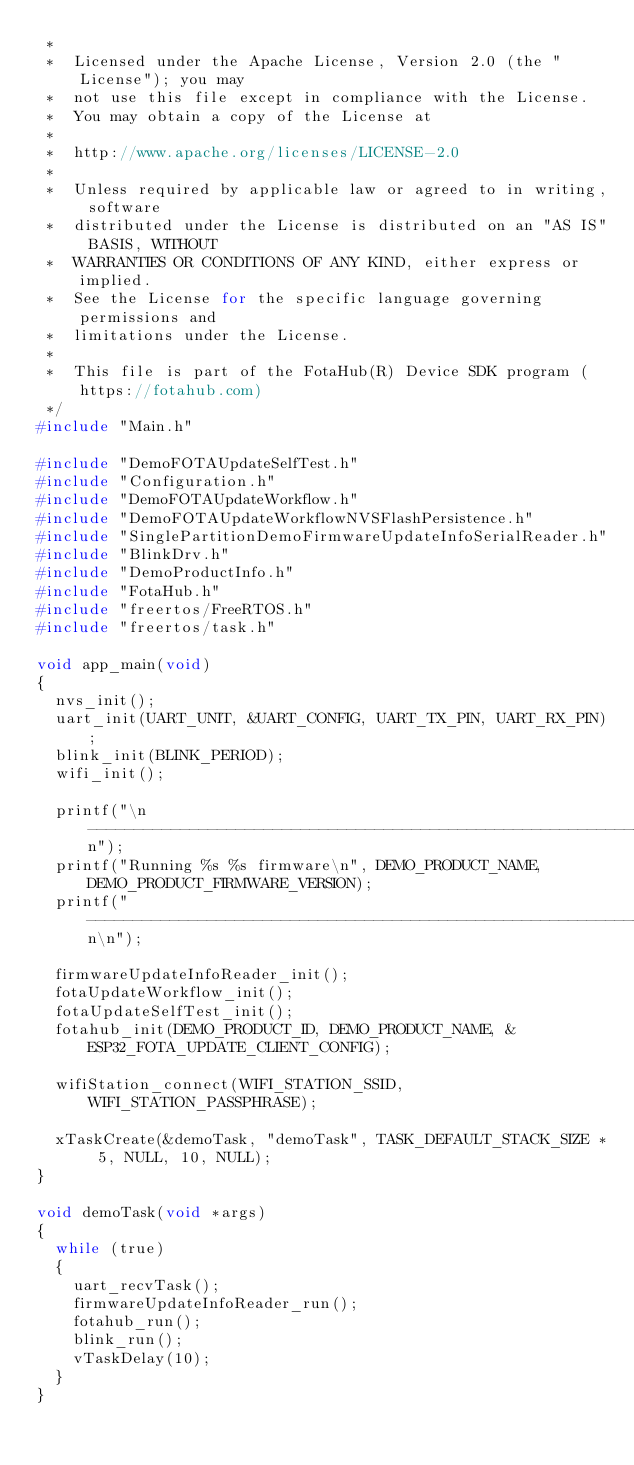<code> <loc_0><loc_0><loc_500><loc_500><_C_> *
 *  Licensed under the Apache License, Version 2.0 (the "License"); you may
 *  not use this file except in compliance with the License.
 *  You may obtain a copy of the License at
 *
 *  http://www.apache.org/licenses/LICENSE-2.0
 *
 *  Unless required by applicable law or agreed to in writing, software
 *  distributed under the License is distributed on an "AS IS" BASIS, WITHOUT
 *  WARRANTIES OR CONDITIONS OF ANY KIND, either express or implied.
 *  See the License for the specific language governing permissions and
 *  limitations under the License.
 *
 *  This file is part of the FotaHub(R) Device SDK program (https://fotahub.com)
 */
#include "Main.h"

#include "DemoFOTAUpdateSelfTest.h"
#include "Configuration.h"
#include "DemoFOTAUpdateWorkflow.h"
#include "DemoFOTAUpdateWorkflowNVSFlashPersistence.h"
#include "SinglePartitionDemoFirmwareUpdateInfoSerialReader.h"
#include "BlinkDrv.h"
#include "DemoProductInfo.h"
#include "FotaHub.h"
#include "freertos/FreeRTOS.h"
#include "freertos/task.h"

void app_main(void)
{
  nvs_init();
  uart_init(UART_UNIT, &UART_CONFIG, UART_TX_PIN, UART_RX_PIN);
  blink_init(BLINK_PERIOD);
  wifi_init();
  
  printf("\n--------------------------------------------------------------------------\n");
  printf("Running %s %s firmware\n", DEMO_PRODUCT_NAME, DEMO_PRODUCT_FIRMWARE_VERSION);
  printf("--------------------------------------------------------------------------\n\n");
  
  firmwareUpdateInfoReader_init();
  fotaUpdateWorkflow_init();
  fotaUpdateSelfTest_init();
  fotahub_init(DEMO_PRODUCT_ID, DEMO_PRODUCT_NAME, &ESP32_FOTA_UPDATE_CLIENT_CONFIG);
  
  wifiStation_connect(WIFI_STATION_SSID, WIFI_STATION_PASSPHRASE);
  
  xTaskCreate(&demoTask, "demoTask", TASK_DEFAULT_STACK_SIZE * 5, NULL, 10, NULL);
}

void demoTask(void *args)
{
  while (true)
  {
    uart_recvTask();
    firmwareUpdateInfoReader_run();
    fotahub_run();
    blink_run();
    vTaskDelay(10);
  }
}
</code> 